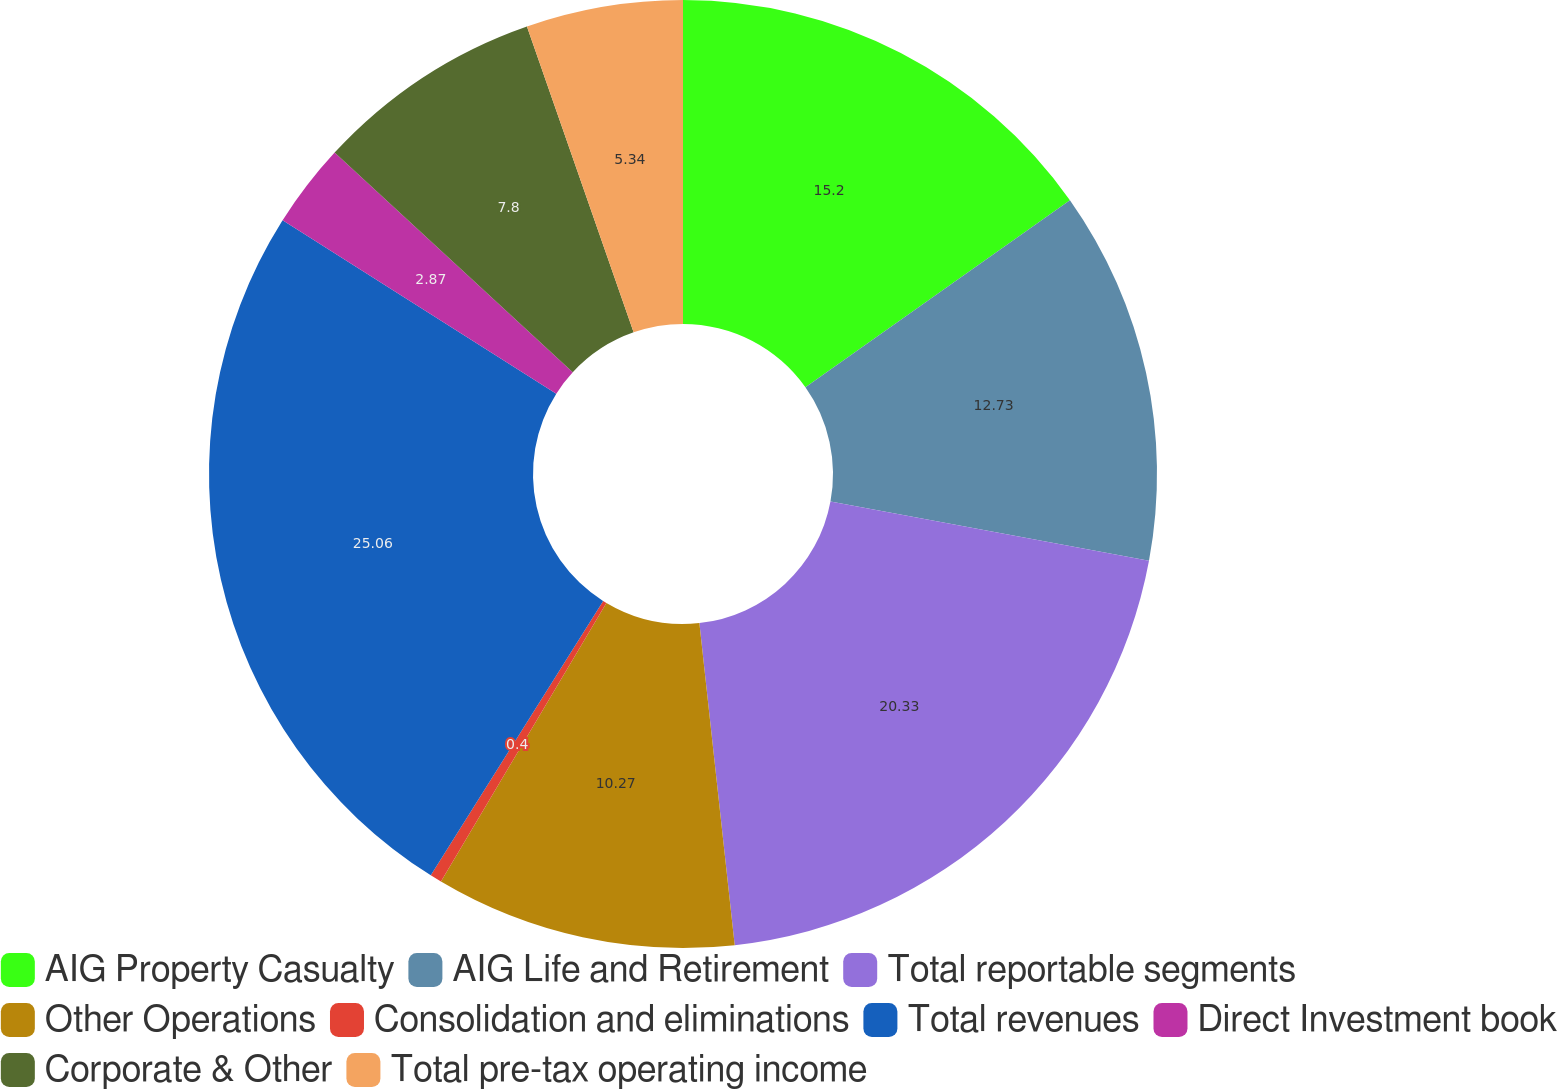Convert chart to OTSL. <chart><loc_0><loc_0><loc_500><loc_500><pie_chart><fcel>AIG Property Casualty<fcel>AIG Life and Retirement<fcel>Total reportable segments<fcel>Other Operations<fcel>Consolidation and eliminations<fcel>Total revenues<fcel>Direct Investment book<fcel>Corporate & Other<fcel>Total pre-tax operating income<nl><fcel>15.2%<fcel>12.73%<fcel>20.33%<fcel>10.27%<fcel>0.4%<fcel>25.06%<fcel>2.87%<fcel>7.8%<fcel>5.34%<nl></chart> 